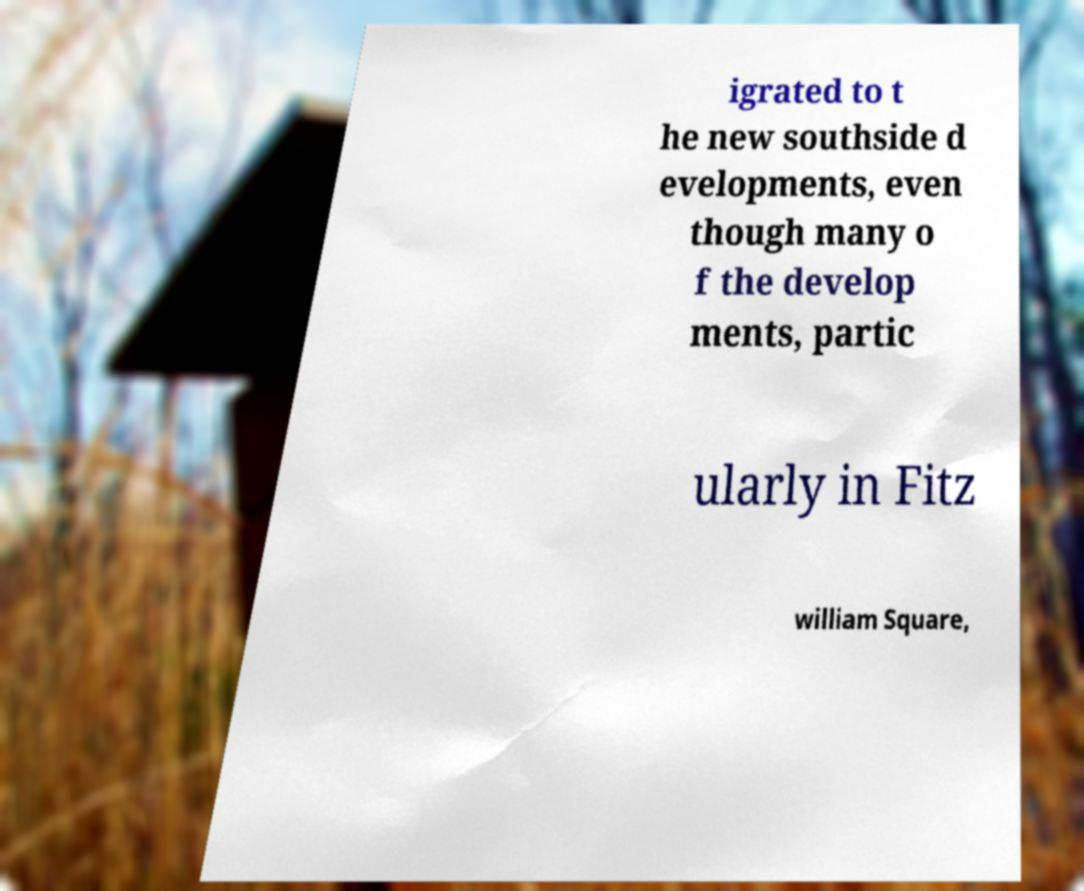I need the written content from this picture converted into text. Can you do that? igrated to t he new southside d evelopments, even though many o f the develop ments, partic ularly in Fitz william Square, 